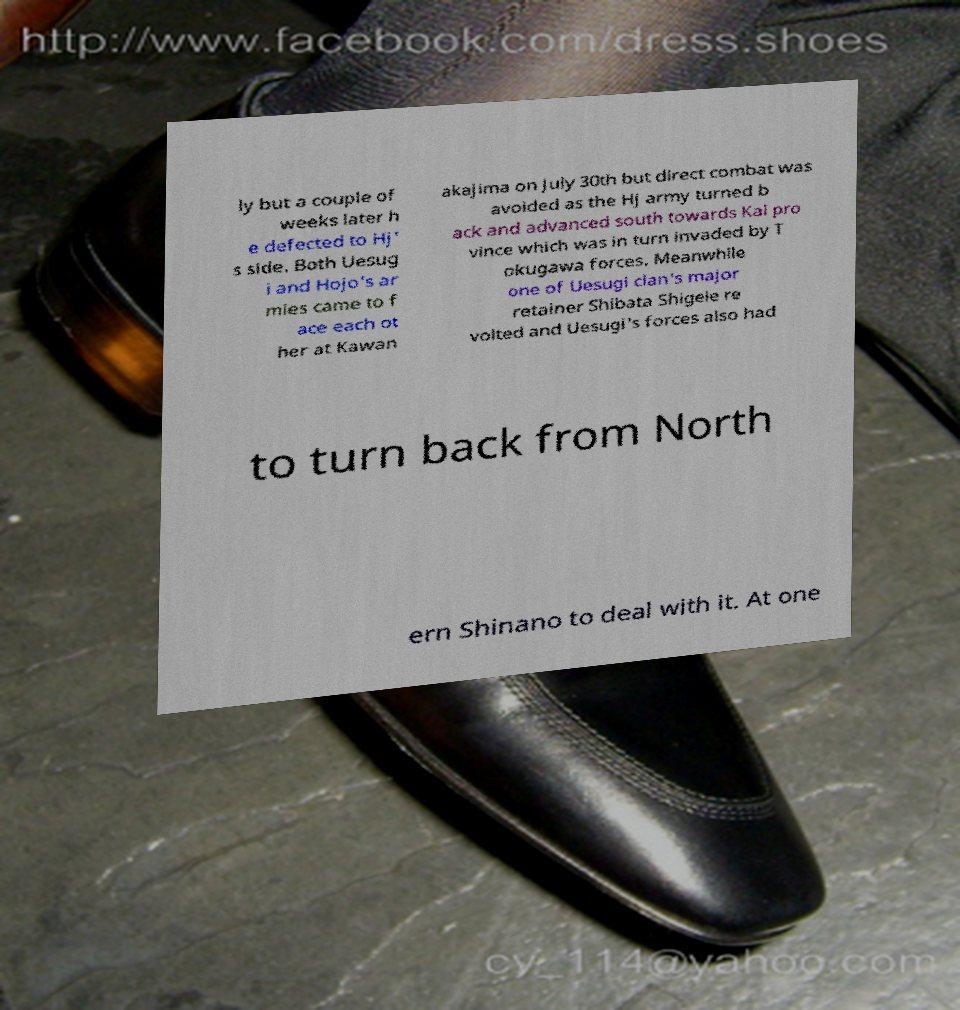There's text embedded in this image that I need extracted. Can you transcribe it verbatim? ly but a couple of weeks later h e defected to Hj' s side. Both Uesug i and Hojo's ar mies came to f ace each ot her at Kawan akajima on July 30th but direct combat was avoided as the Hj army turned b ack and advanced south towards Kai pro vince which was in turn invaded by T okugawa forces. Meanwhile one of Uesugi clan's major retainer Shibata Shigeie re volted and Uesugi's forces also had to turn back from North ern Shinano to deal with it. At one 